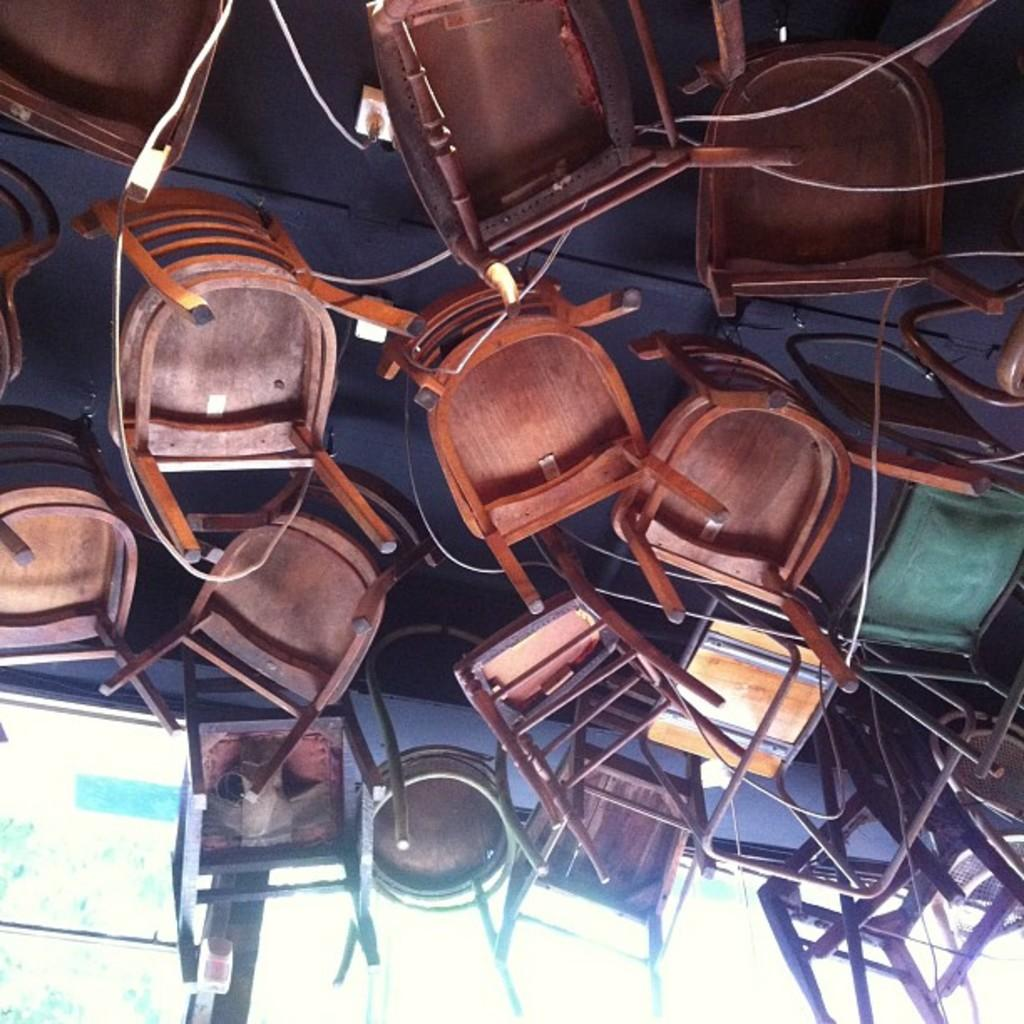What type of furniture is on the floor in the image? There are chairs on the floor in the image. What else can be seen in the image besides the chairs? There are cables visible in the image. What is in front of the chairs? There is a glass window in front of the chairs. What type of pump is used to organize the cables in the image? There is no pump or cable organization system visible in the image. 